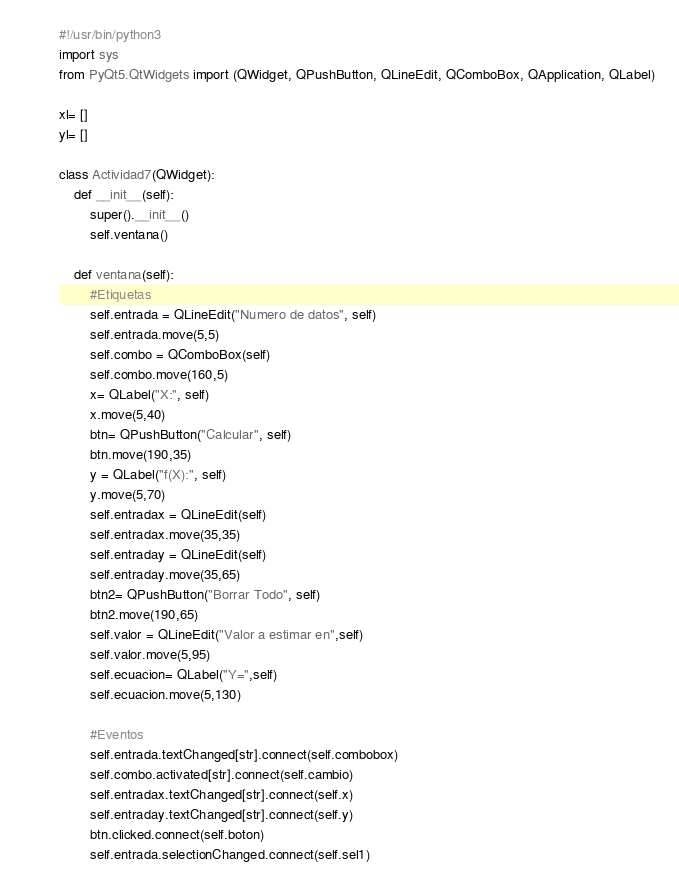Convert code to text. <code><loc_0><loc_0><loc_500><loc_500><_Python_>#!/usr/bin/python3
import sys
from PyQt5.QtWidgets import (QWidget, QPushButton, QLineEdit, QComboBox, QApplication, QLabel)

xl= []
yl= []

class Actividad7(QWidget):
	def __init__(self):
		super().__init__()
		self.ventana()
		
	def ventana(self):
		#Etiquetas
		self.entrada = QLineEdit("Numero de datos", self)
		self.entrada.move(5,5)
		self.combo = QComboBox(self)
		self.combo.move(160,5)
		x= QLabel("X:", self)
		x.move(5,40)
		btn= QPushButton("Calcular", self)
		btn.move(190,35)
		y = QLabel("f(X):", self)
		y.move(5,70)
		self.entradax = QLineEdit(self)
		self.entradax.move(35,35)
		self.entraday = QLineEdit(self)
		self.entraday.move(35,65)
		btn2= QPushButton("Borrar Todo", self)
		btn2.move(190,65)
		self.valor = QLineEdit("Valor a estimar en",self)
		self.valor.move(5,95)
		self.ecuacion= QLabel("Y=",self)
		self.ecuacion.move(5,130)

		#Eventos
		self.entrada.textChanged[str].connect(self.combobox)
		self.combo.activated[str].connect(self.cambio)
		self.entradax.textChanged[str].connect(self.x)
		self.entraday.textChanged[str].connect(self.y)
		btn.clicked.connect(self.boton)
		self.entrada.selectionChanged.connect(self.sel1)</code> 